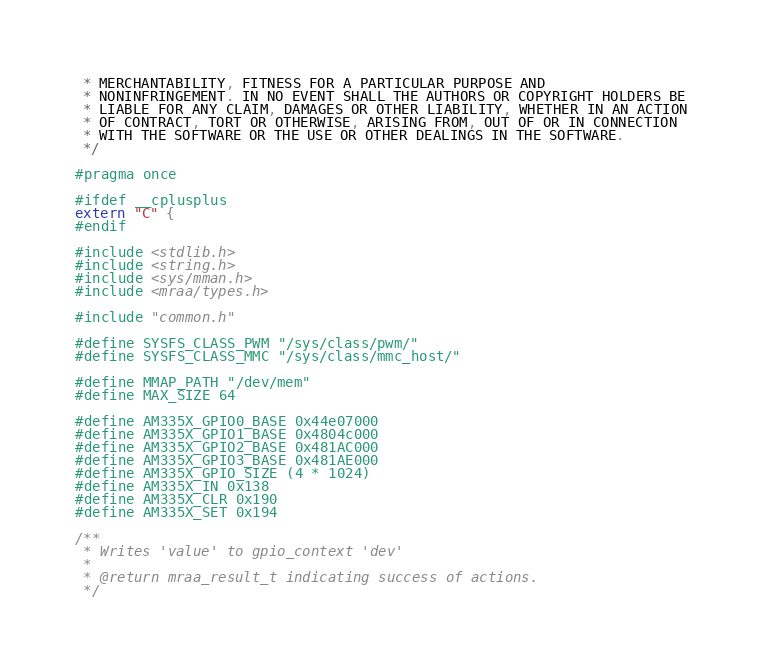Convert code to text. <code><loc_0><loc_0><loc_500><loc_500><_C_> * MERCHANTABILITY, FITNESS FOR A PARTICULAR PURPOSE AND
 * NONINFRINGEMENT. IN NO EVENT SHALL THE AUTHORS OR COPYRIGHT HOLDERS BE
 * LIABLE FOR ANY CLAIM, DAMAGES OR OTHER LIABILITY, WHETHER IN AN ACTION
 * OF CONTRACT, TORT OR OTHERWISE, ARISING FROM, OUT OF OR IN CONNECTION
 * WITH THE SOFTWARE OR THE USE OR OTHER DEALINGS IN THE SOFTWARE.
 */

#pragma once

#ifdef __cplusplus
extern "C" {
#endif

#include <stdlib.h>
#include <string.h>
#include <sys/mman.h>
#include <mraa/types.h>

#include "common.h"

#define SYSFS_CLASS_PWM "/sys/class/pwm/"
#define SYSFS_CLASS_MMC "/sys/class/mmc_host/"

#define MMAP_PATH "/dev/mem"
#define MAX_SIZE 64

#define AM335X_GPIO0_BASE 0x44e07000
#define AM335X_GPIO1_BASE 0x4804c000
#define AM335X_GPIO2_BASE 0x481AC000
#define AM335X_GPIO3_BASE 0x481AE000
#define AM335X_GPIO_SIZE (4 * 1024)
#define AM335X_IN 0x138
#define AM335X_CLR 0x190
#define AM335X_SET 0x194

/**
 * Writes 'value' to gpio_context 'dev'
 *
 * @return mraa_result_t indicating success of actions.
 */</code> 